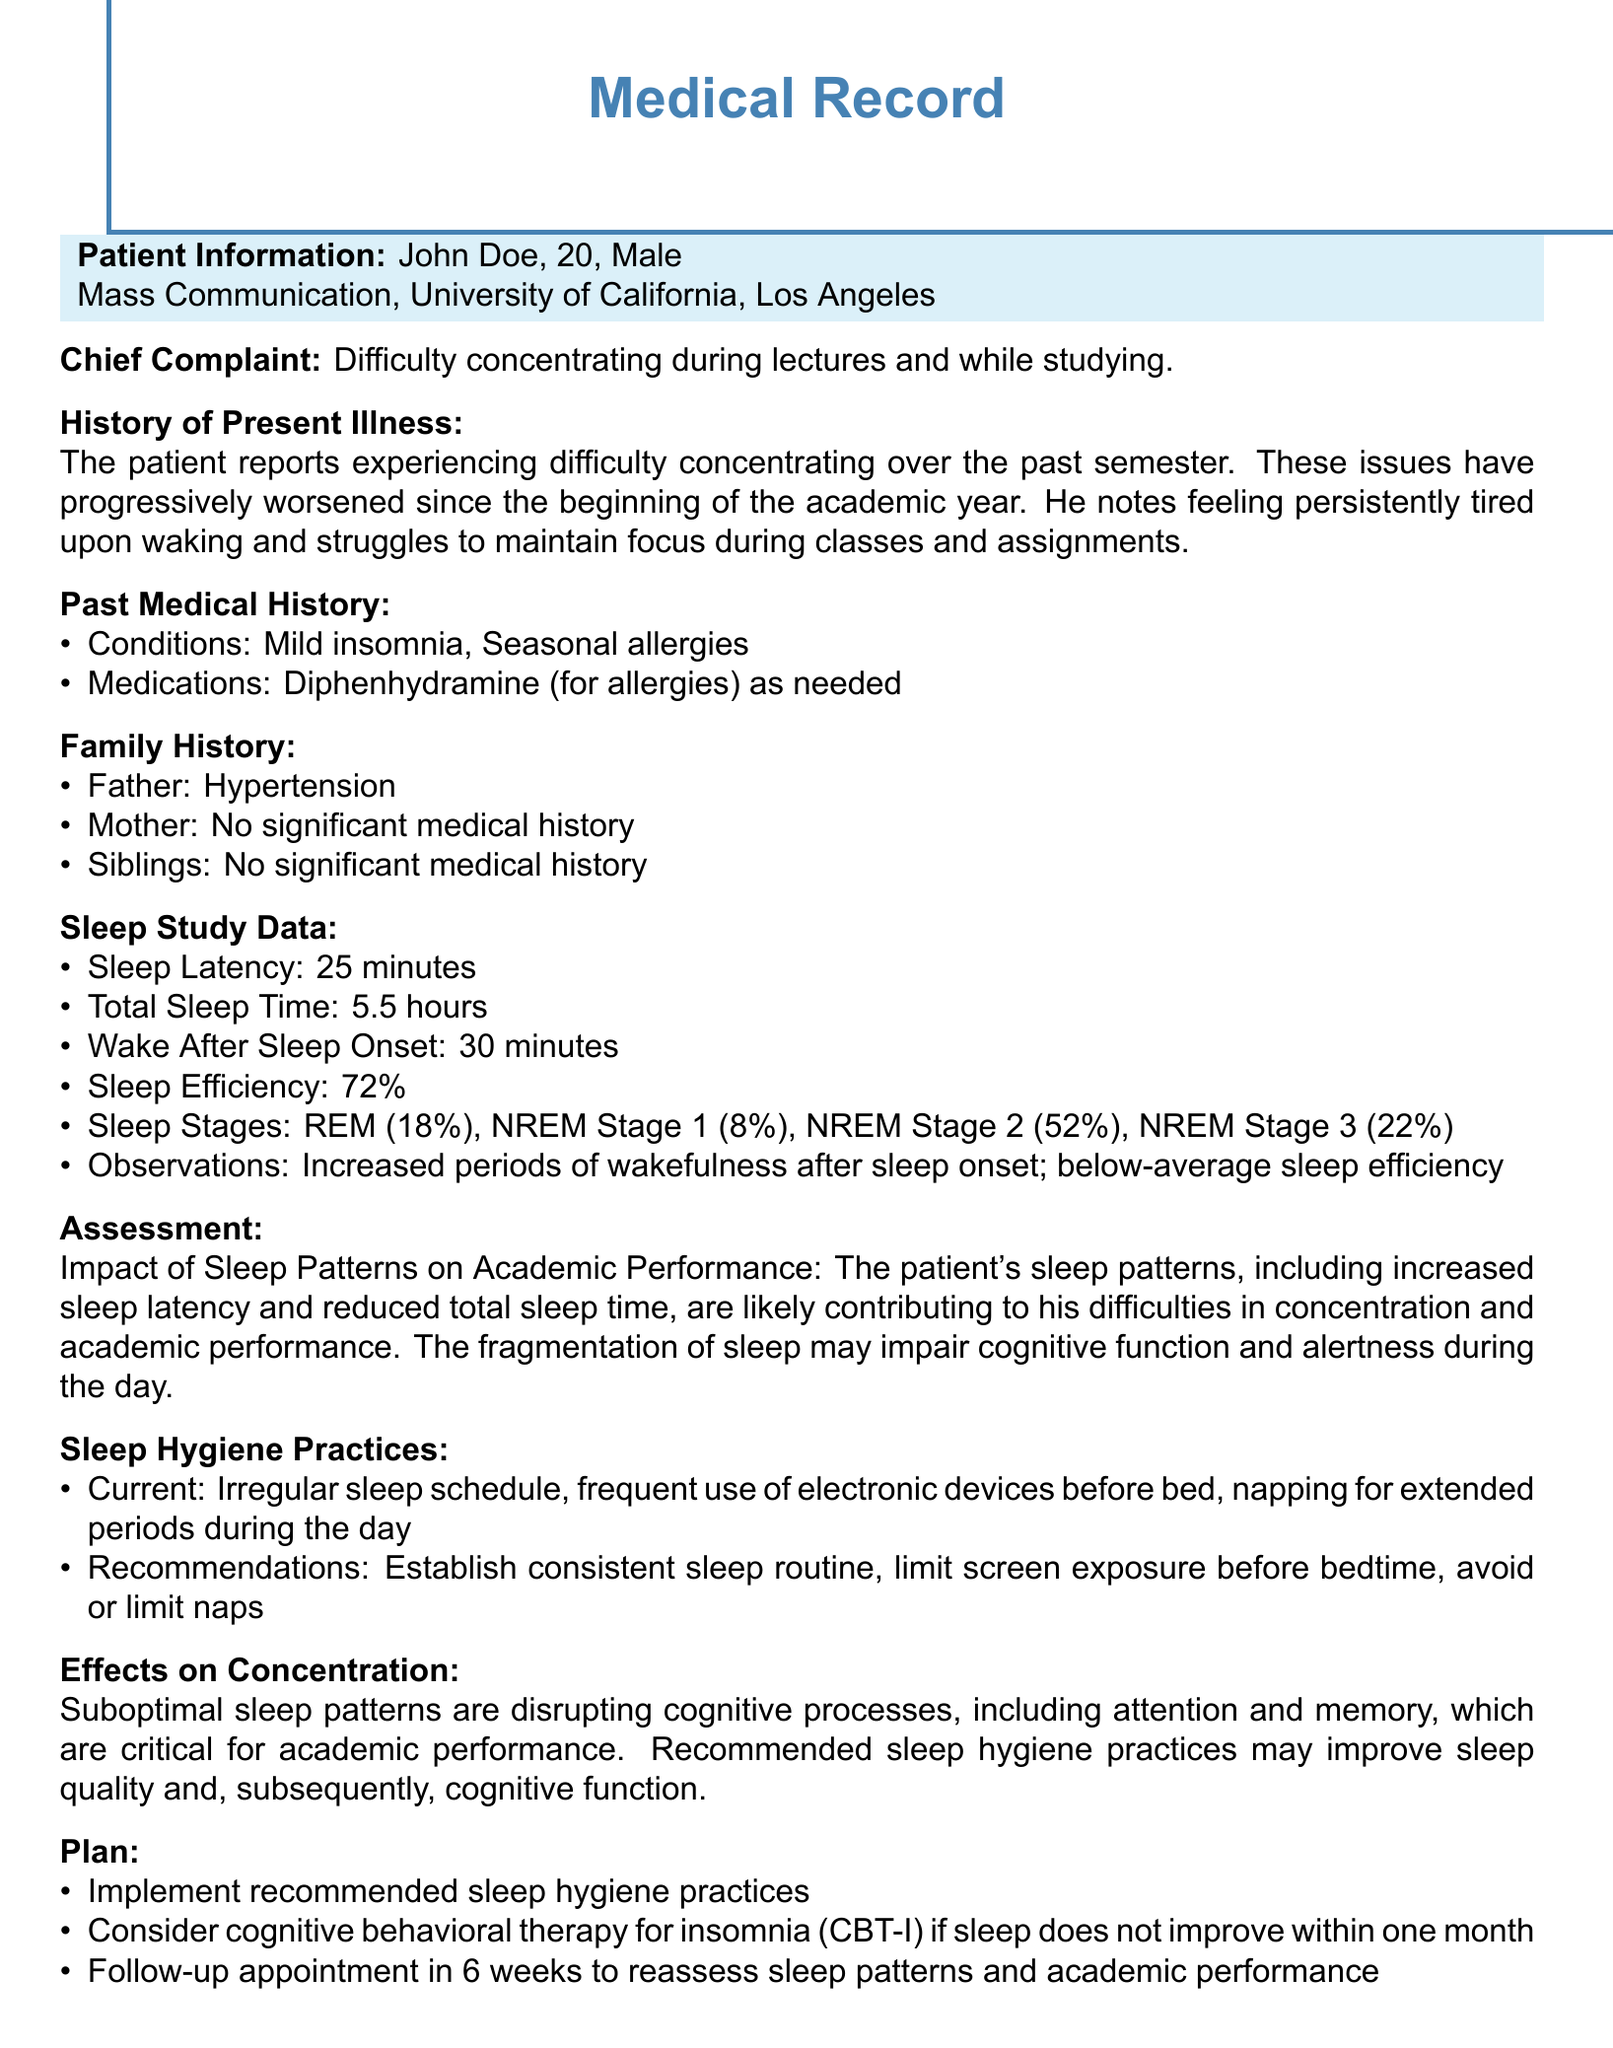what is the patient's name? The patient's name is mentioned in the patient information section of the document.
Answer: John Doe what is the age of the patient? The patient's age is specified in the patient information section.
Answer: 20 what is the total sleep time reported? Total sleep time is listed in the sleep study data section.
Answer: 5.5 hours what medical history does the patient have? The past medical history itemizes the patient's conditions.
Answer: Mild insomnia, Seasonal allergies what is the sleep efficiency percentage? Sleep efficiency is noted in the sleep study data.
Answer: 72% what recommendations are made for sleep hygiene practices? The recommendations are provided under the sleep hygiene practices section.
Answer: Establish consistent sleep routine, limit screen exposure before bedtime, avoid or limit naps how long is the follow-up appointment scheduled for? The plan section specifies the timeline for the follow-up.
Answer: 6 weeks what are the effects of suboptimal sleep patterns on concentration? The document specifies the impact on cognitive processes in the effects section.
Answer: Disrupting cognitive processes what type of therapy may be considered if sleep does not improve? The plan section suggests a specific therapy type for insomnia.
Answer: Cognitive behavioral therapy for insomnia (CBT-I) 